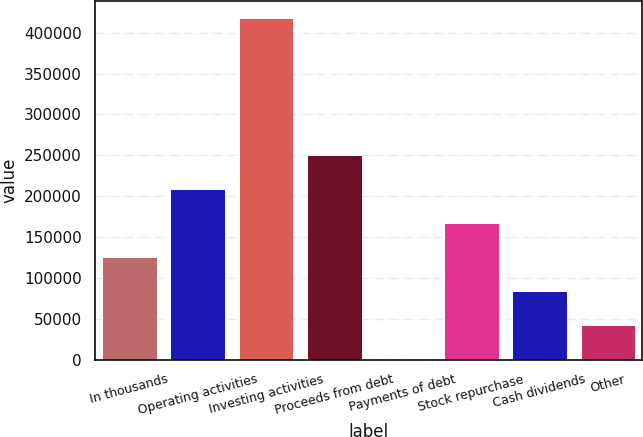Convert chart. <chart><loc_0><loc_0><loc_500><loc_500><bar_chart><fcel>In thousands<fcel>Operating activities<fcel>Investing activities<fcel>Proceeds from debt<fcel>Payments of debt<fcel>Stock repurchase<fcel>Cash dividends<fcel>Other<nl><fcel>125502<fcel>208913<fcel>417441<fcel>250619<fcel>385<fcel>167207<fcel>83796.2<fcel>42090.6<nl></chart> 